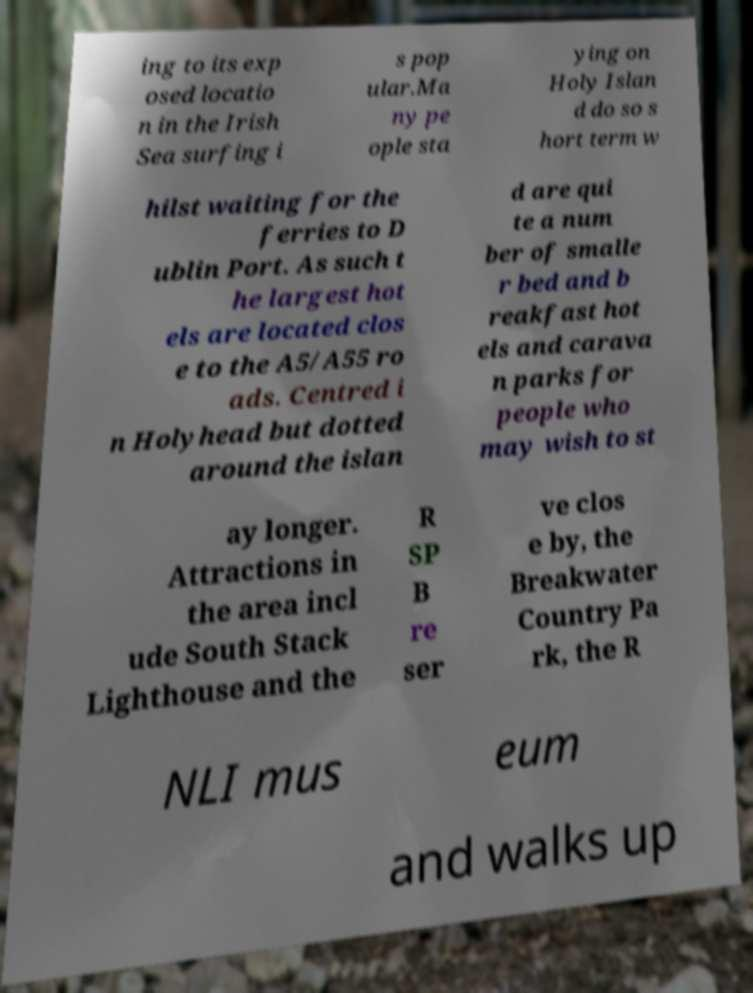Please read and relay the text visible in this image. What does it say? ing to its exp osed locatio n in the Irish Sea surfing i s pop ular.Ma ny pe ople sta ying on Holy Islan d do so s hort term w hilst waiting for the ferries to D ublin Port. As such t he largest hot els are located clos e to the A5/A55 ro ads. Centred i n Holyhead but dotted around the islan d are qui te a num ber of smalle r bed and b reakfast hot els and carava n parks for people who may wish to st ay longer. Attractions in the area incl ude South Stack Lighthouse and the R SP B re ser ve clos e by, the Breakwater Country Pa rk, the R NLI mus eum and walks up 